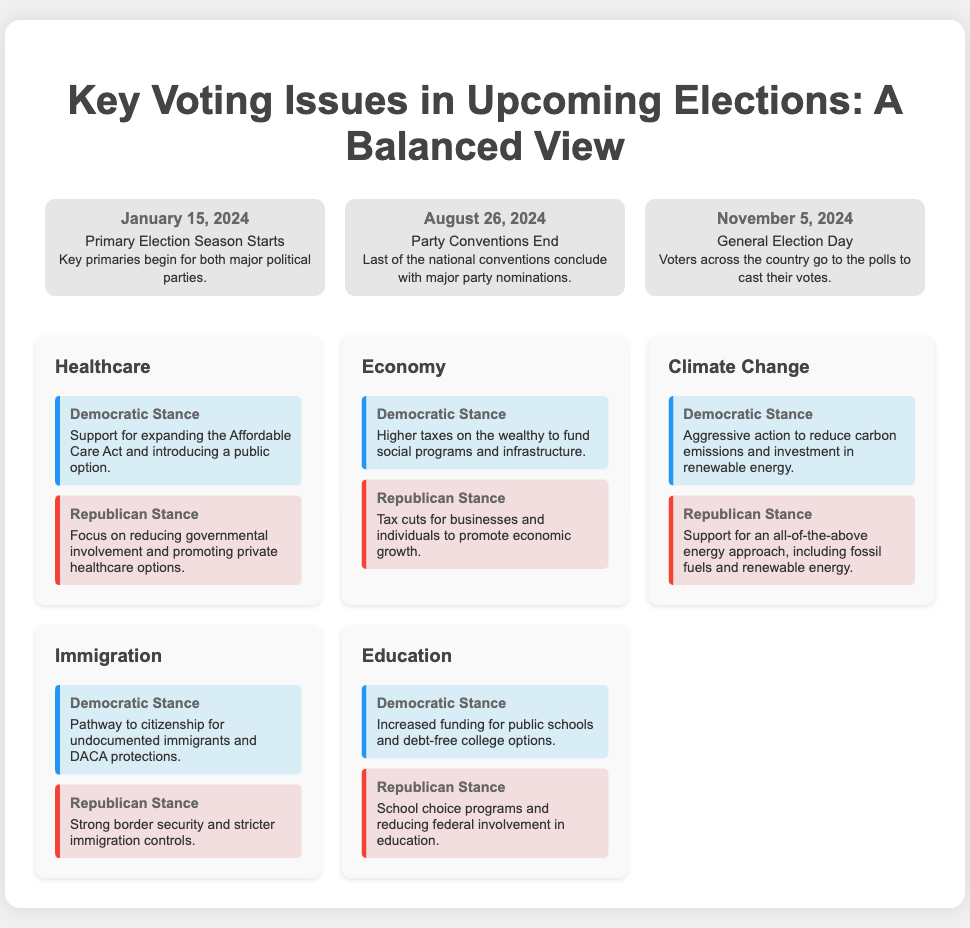What date do the primary elections start? The primary elections start on January 15, 2024, as indicated in the timeline.
Answer: January 15, 2024 What is the Democratic stance on healthcare? The Democratic stance on healthcare supports expanding the Affordable Care Act and introducing a public option, as stated in the issues section.
Answer: Support for expanding the Affordable Care Act and introducing a public option What occurs on November 5, 2024? November 5, 2024 is the General Election Day when voters cast their votes, as mentioned in the timeline.
Answer: General Election Day What is the Republican stance on economy? The Republican stance on the economy emphasizes tax cuts for businesses and individuals to promote economic growth.
Answer: Tax cuts for businesses and individuals to promote economic growth Which major voting issue includes a pathway to citizenship? The voting issue that includes a pathway to citizenship is Immigration, as described in the issues section.
Answer: Immigration What event marks the end of party conventions? The end of party conventions is marked on August 26, 2024, according to the timeline.
Answer: August 26, 2024 What do Democrats propose regarding education? Democrats propose increased funding for public schools and debt-free college options, as stated in the issues section.
Answer: Increased funding for public schools and debt-free college options Which issue has aggressive action to reduce carbon emissions in the Democratic stance? The issue that discusses aggressive action to reduce carbon emissions in the Democratic stance is Climate Change.
Answer: Climate Change What is the stance of Republicans on climate change? The Republican stance on climate change supports an all-of-the-above energy approach, including fossil fuels and renewable energy.
Answer: Support for an all-of-the-above energy approach, including fossil fuels and renewable energy 